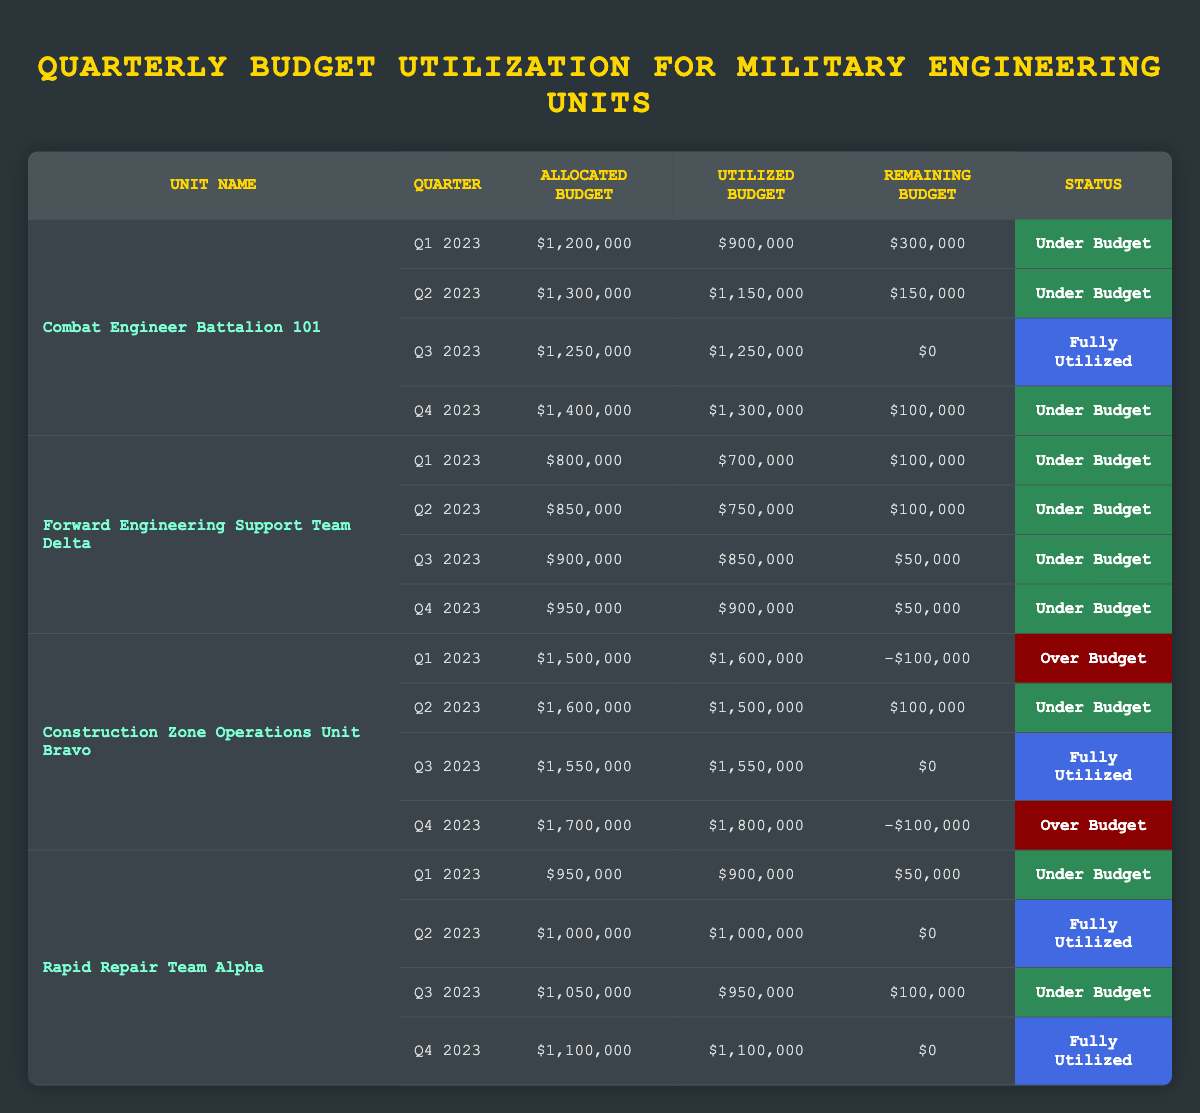What is the remaining budget for the Forward Engineering Support Team Delta in Q2 2023? The remaining budget for the Forward Engineering Support Team Delta can be found in the Q2 2023 row, where it states a remaining budget of $100,000.
Answer: $100,000 How much budget was utilized by the Combat Engineer Battalion 101 in Q3 2023? In Q3 2023, the Combat Engineer Battalion 101 utilized a budget of $1,250,000, as indicated in its respective row for that quarter.
Answer: $1,250,000 Which unit had an over-budget status in Q1 2023? By checking the Q1 2023 rows, the Construction Zone Operations Unit Bravo shows a remaining budget of -$100,000, indicating it was over budget.
Answer: Construction Zone Operations Unit Bravo What is the total allocated budget for the Rapid Repair Team Alpha for 2023? To find the total allocated budget for 2023, we add the allocated budgets for each quarter (Q1: $950,000, Q2: $1,000,000, Q3: $1,050,000, Q4: $1,100,000). So, the total is $950,000 + $1,000,000 + $1,050,000 + $1,100,000 = $4,100,000.
Answer: $4,100,000 Which quarter had the highest utilized budget for Construction Zone Operations Unit Bravo? The highest utilized budget for Construction Zone Operations Unit Bravo can be determined by comparing all quarters. Q1 2023 has $1,600,000, while Q2 and Q3 have $1,500,000 and $1,550,000 respectively, and Q4 has $1,800,000. Hence, Q4 2023 shows the highest utilized budget.
Answer: Q4 2023 What percentage of the allocated budget was utilized by the Rapid Repair Team Alpha in Q2 2023? The percentage utilized is calculated by taking the utilized budget ($1,000,000) divided by the allocated budget ($1,000,000) and multiplying by 100. Thus, (1,000,000 / 1,000,000) * 100 = 100%.
Answer: 100% Did any unit fully utilize their budget in Q1 2023? By examining the statuses for Q1 2023, none of the units is marked as "Fully Utilized." They are either "Under Budget" or "Over Budget."
Answer: No Which unit had the least remaining budget in Q4 2023? In Q4 2023, by assessing remaining budgets, Construction Zone Operations Unit Bravo shows a remaining budget of -$100,000, which is the lowest compared to other units that are under budget.
Answer: Construction Zone Operations Unit Bravo What is the average utilized budget across all units in Q3 2023? First, the utilized budgets for Q3 2023 are noted: Combat Engineer Battalion 101 ($1,250,000), Forward Engineering Support Team Delta ($850,000), Construction Zone Operations Unit Bravo ($1,550,000), and Rapid Repair Team Alpha ($950,000). The total is $1,250,000 + $850,000 + $1,550,000 + $950,000 = $4,600,000. The average is then $4,600,000 divided by 4 units, resulting in $1,150,000.
Answer: $1,150,000 In which quarter did the Forward Engineering Support Team Delta utilize exactly $750,000? The data indicates that the Forward Engineering Support Team Delta utilized exactly $750,000 in Q2 2023. This is noted in the row for that quarter specifically.
Answer: Q2 2023 How many total quarters did the Combat Engineer Battalion 101 remain under budget? The Combat Engineer Battalion 101 was under budget in Q1, Q2, and Q4 of 2023, marking a total of three quarters. This can be confirmed by reviewing the statuses for each quarter.
Answer: 3 quarters 